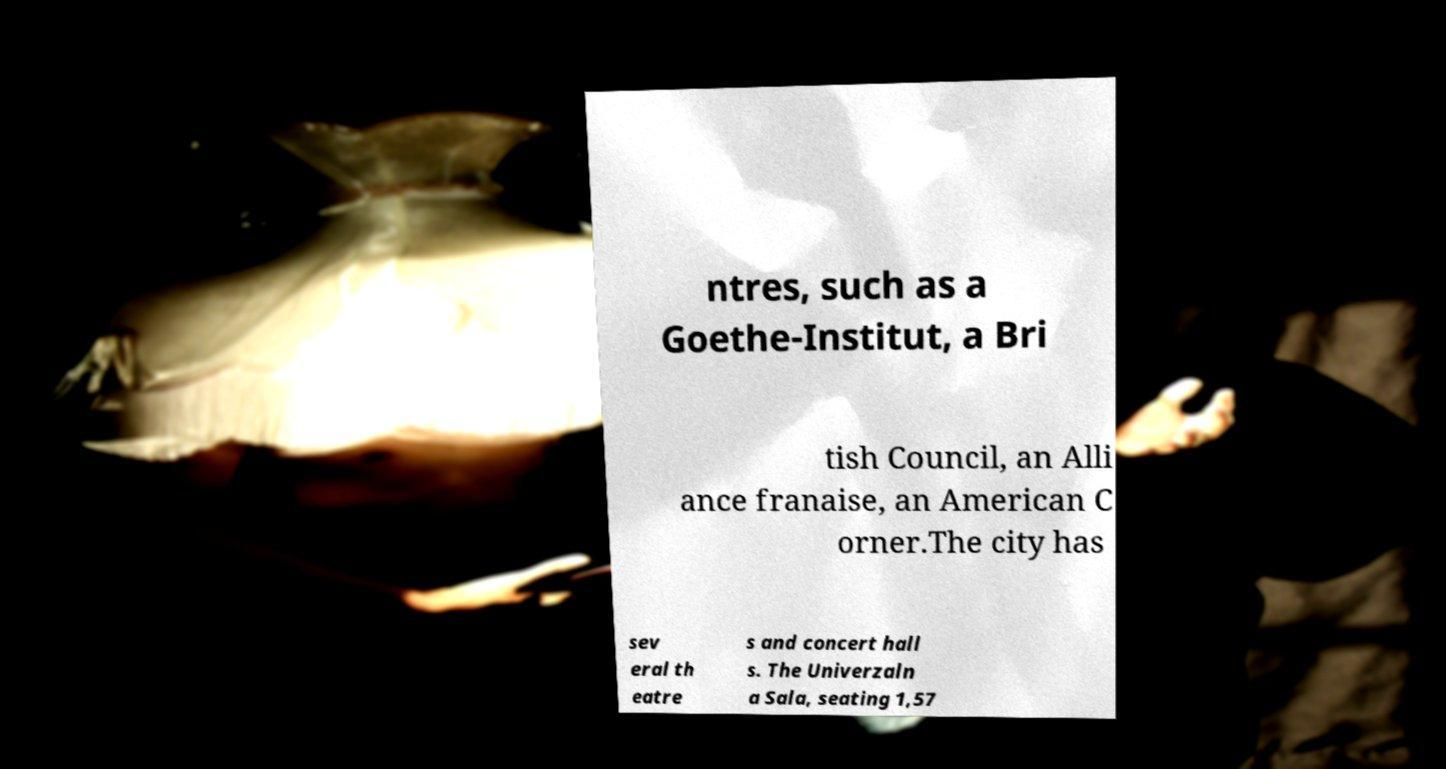Please identify and transcribe the text found in this image. ntres, such as a Goethe-Institut, a Bri tish Council, an Alli ance franaise, an American C orner.The city has sev eral th eatre s and concert hall s. The Univerzaln a Sala, seating 1,57 